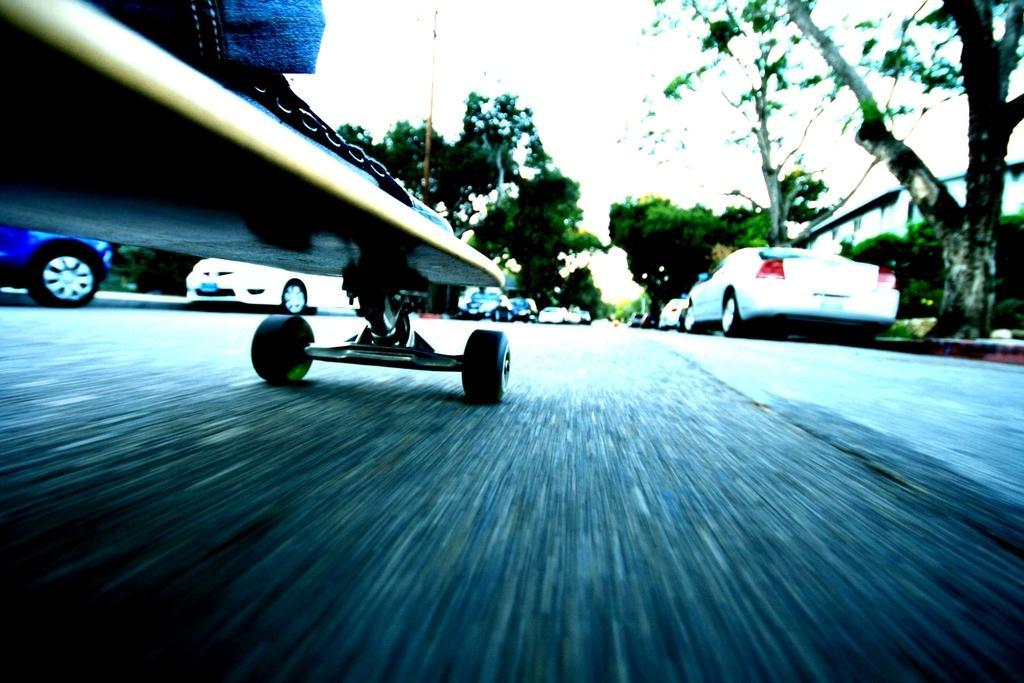Describe this image in one or two sentences. In this image we can see the skateboard. And right top we can see trees. And cars images are also seen in middle. And we can see sky at the top. 